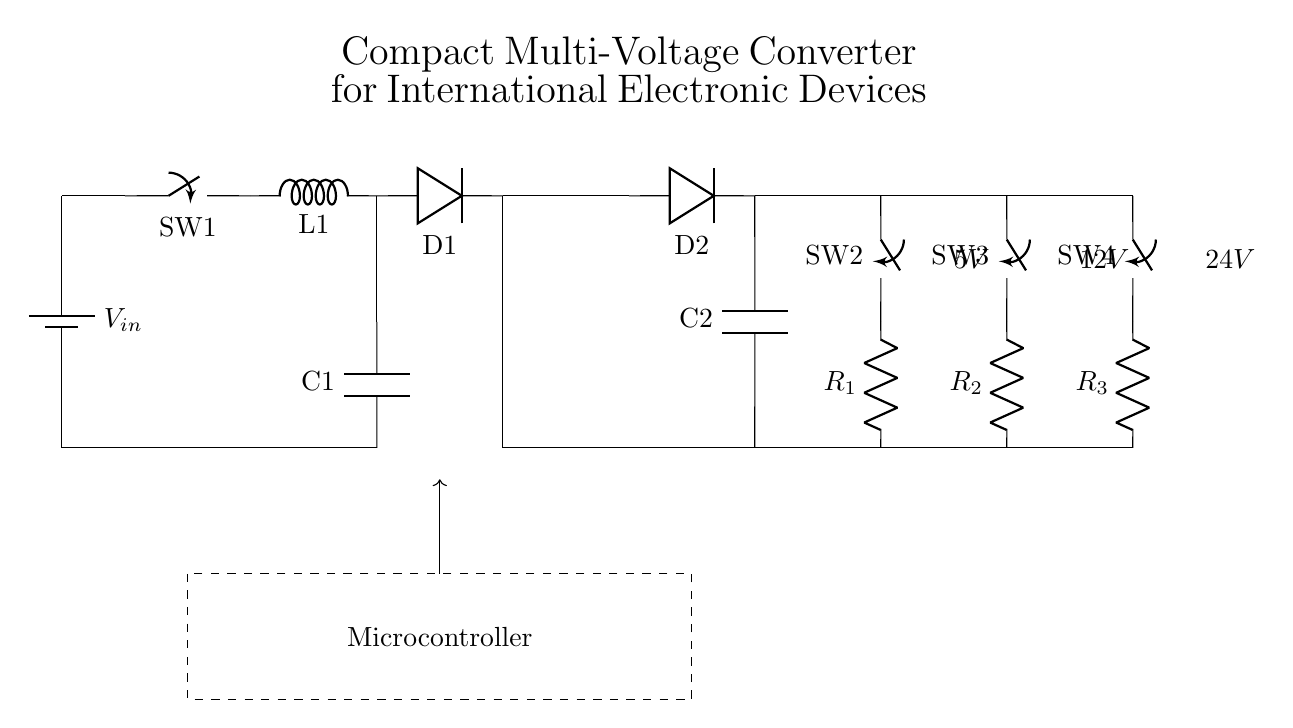What are the voltage outputs of the circuit? The circuit provides three voltage outputs: 5V, 12V, and 24V, indicated next to the respective components labeled as outputs 1, 2, and 3.
Answer: 5V, 12V, 24V What type of converter is used in this circuit? The circuit uses a buck-boost converter, as can be identified by the switch, inductor, and diode connected together in a specific configuration that allows both step-up and step-down voltage conversion.
Answer: Buck-Boost Converter What component regulates the voltage output? The output voltage is regulated by the microcontroller, which monitors and adjusts the circuit's operation to attain the desired voltage levels as indicated in the labeled dashed box in the diagram.
Answer: Microcontroller How many diodes are used in the circuit? There are two diodes indicated in the circuit diagram, labeled D1 and D2, which are part of the buck-boost converter and the rectifier section.
Answer: Two What is the function of the flyback transformer in this circuit? The flyback transformer is used to isolate and transfer energy between the input and output while enabling voltage feedback to the system for regulation; it converts the input energy efficiently to the desired output voltages.
Answer: Energy Transfer Which component is connected to the highest voltage output? The output connected to the highest voltage, which is 24V in this circuit, is linked to R3. This can be determined by tracing the connections from the outputs to the resistors at the end of the circuit.
Answer: R3 